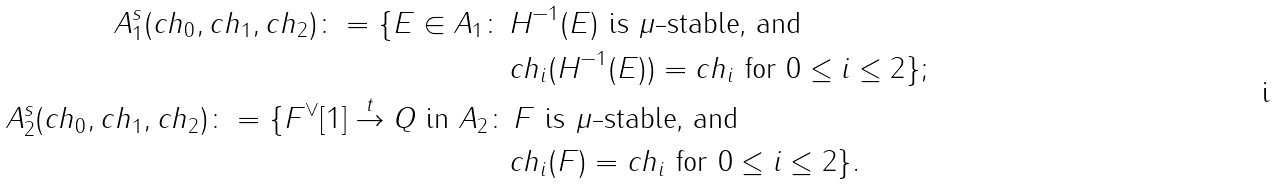Convert formula to latex. <formula><loc_0><loc_0><loc_500><loc_500>A _ { 1 } ^ { s } ( c h _ { 0 } , c h _ { 1 } , c h _ { 2 } ) \colon = \{ E \in A _ { 1 } \colon \, & H ^ { - 1 } ( E ) \text { is $\mu$-stable, and} \\ & c h _ { i } ( H ^ { - 1 } ( E ) ) = c h _ { i } \text { for $0\leq i \leq 2$} \} ; \\ A _ { 2 } ^ { s } ( c h _ { 0 } , c h _ { 1 } , c h _ { 2 } ) \colon = \{ F ^ { \vee } [ 1 ] \overset { t } { \to } Q \text { in } A _ { 2 } \colon & \, F \text { is $\mu$-stable, and} \\ & c h _ { i } ( F ) = c h _ { i } \text { for $0\leq i \leq 2$} \} .</formula> 